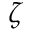<formula> <loc_0><loc_0><loc_500><loc_500>\zeta</formula> 